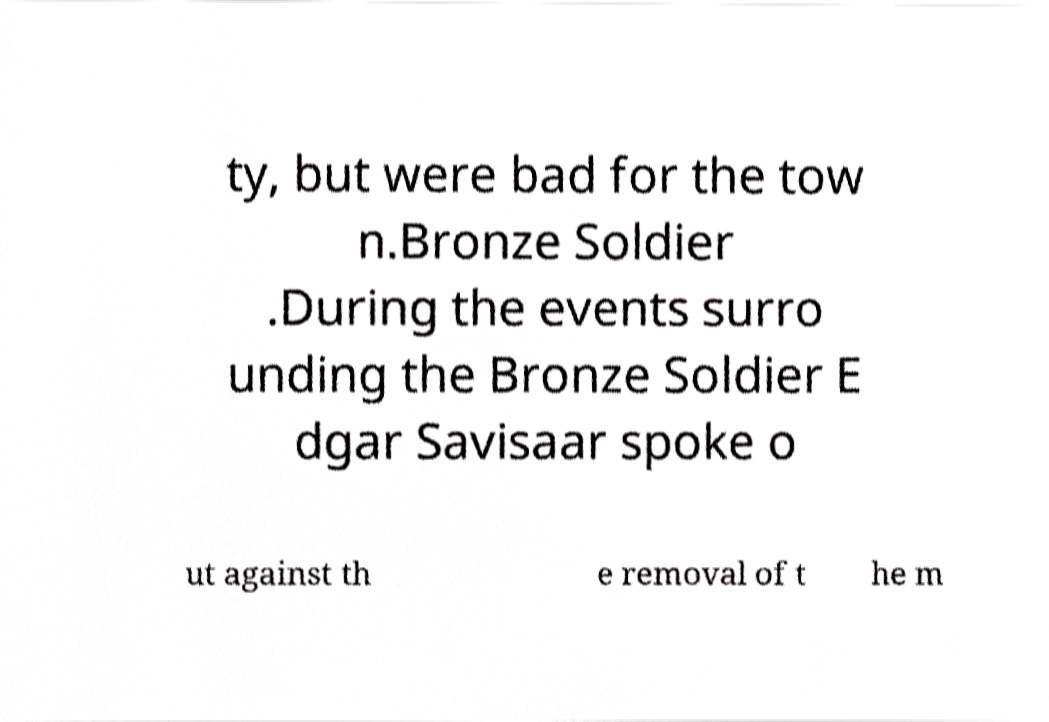There's text embedded in this image that I need extracted. Can you transcribe it verbatim? ty, but were bad for the tow n.Bronze Soldier .During the events surro unding the Bronze Soldier E dgar Savisaar spoke o ut against th e removal of t he m 